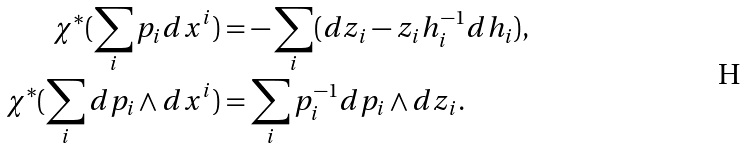<formula> <loc_0><loc_0><loc_500><loc_500>\chi ^ { * } ( \sum _ { i } p _ { i } d x ^ { i } ) & = - \sum _ { i } ( d z _ { i } - z _ { i } h _ { i } ^ { - 1 } d h _ { i } ) , \\ \chi ^ { * } ( \sum _ { i } d p _ { i } \wedge d x ^ { i } ) & = \sum _ { i } p ^ { - 1 } _ { i } d p _ { i } \wedge d z _ { i } .</formula> 